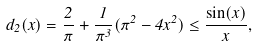Convert formula to latex. <formula><loc_0><loc_0><loc_500><loc_500>d _ { 2 } ( x ) = \frac { 2 } { \pi } + \frac { 1 } { \pi ^ { 3 } } ( \pi ^ { 2 } - 4 x ^ { 2 } ) \leq \frac { \sin ( x ) } { x } ,</formula> 